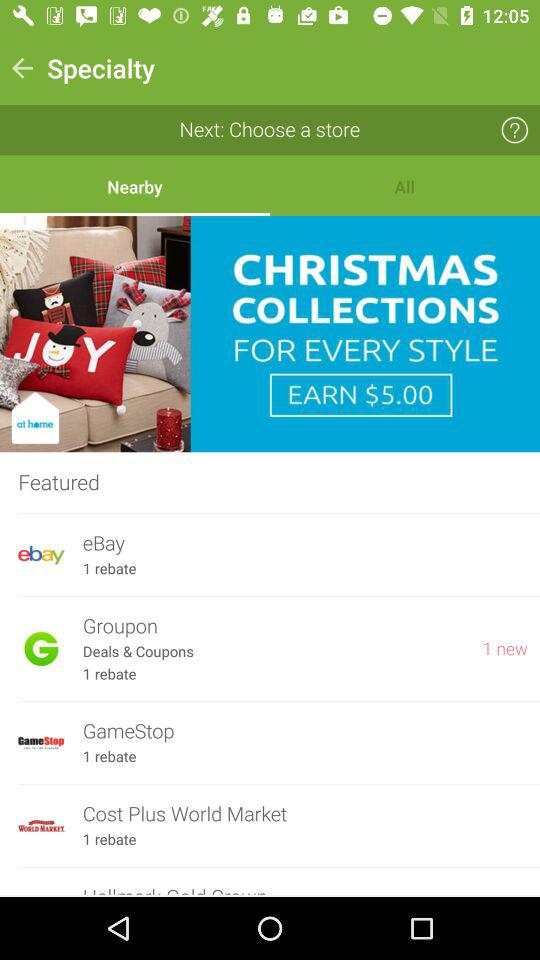How many rebates are there on eBay? There is 1 rebate on eBay. 